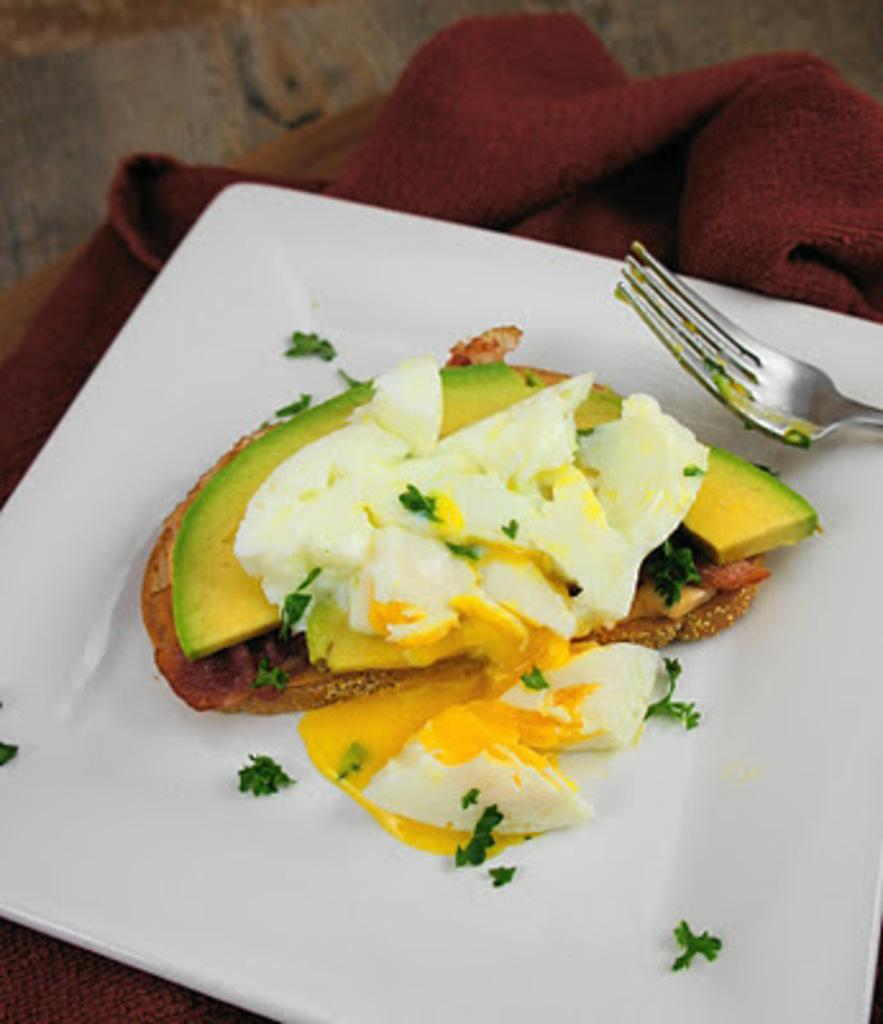What is present in the image related to eating? There is food in the image, as well as a spoon. How is the food being served or contained? The food is in a plate. What is the plate placed on? The plate is placed on a cloth. How does the food receive its mail in the image? The food does not receive mail in the image, as mail is not relevant to the context of the image. What type of punishment is being administered to the food in the image? There is no punishment being administered to the food in the image; it is simply being served on a plate. 